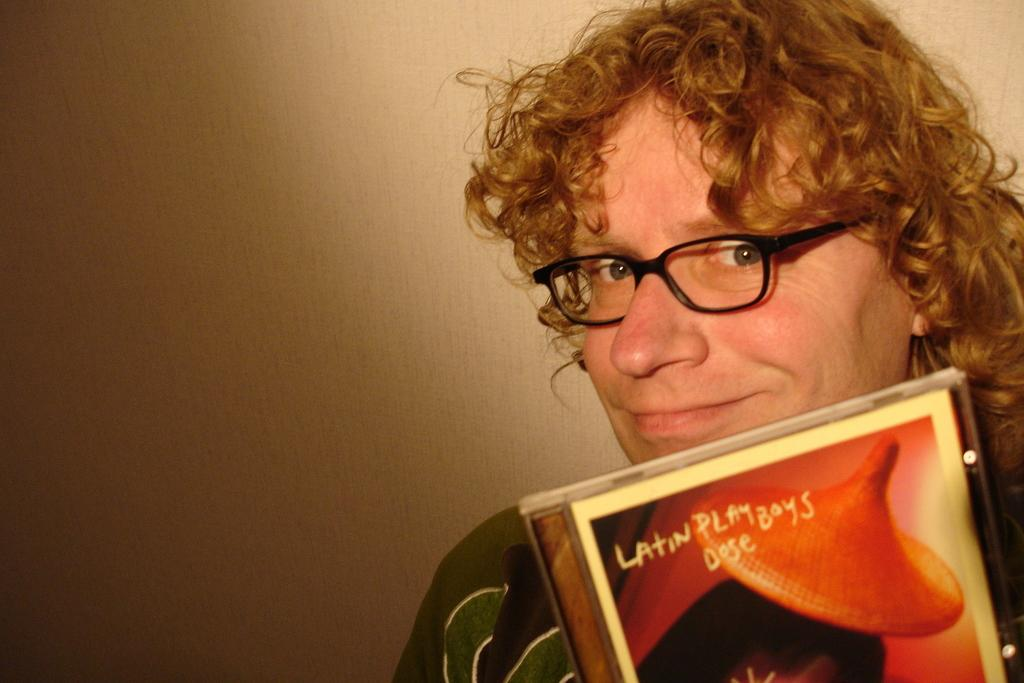What can be seen in the image? There is a person in the image. Can you describe the person's attire? The person is wearing a dress and specs. What is the person holding in the image? The person is holding an object. What color is the background of the image? The background of the image is cream-colored. What type of stamp can be seen on the person's forehead in the image? There is no stamp visible on the person's forehead in the image. 